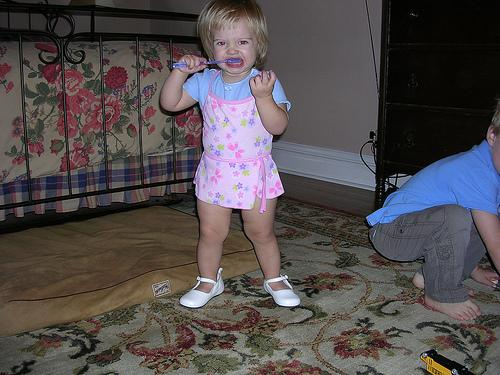Question: how many people are shown?
Choices:
A. 7.
B. 8.
C. 2.
D. 9.
Answer with the letter. Answer: C Question: where is this photo taken?
Choices:
A. Bedroom.
B. In a car.
C. At a shoe store.
D. At a barber shop.
Answer with the letter. Answer: A Question: what color is the toothbrush?
Choices:
A. White.
B. Purple.
C. Green.
D. Yellow.
Answer with the letter. Answer: B Question: who is standing?
Choices:
A. The girl.
B. The batter.
C. The pitcher.
D. The spectator.
Answer with the letter. Answer: A 